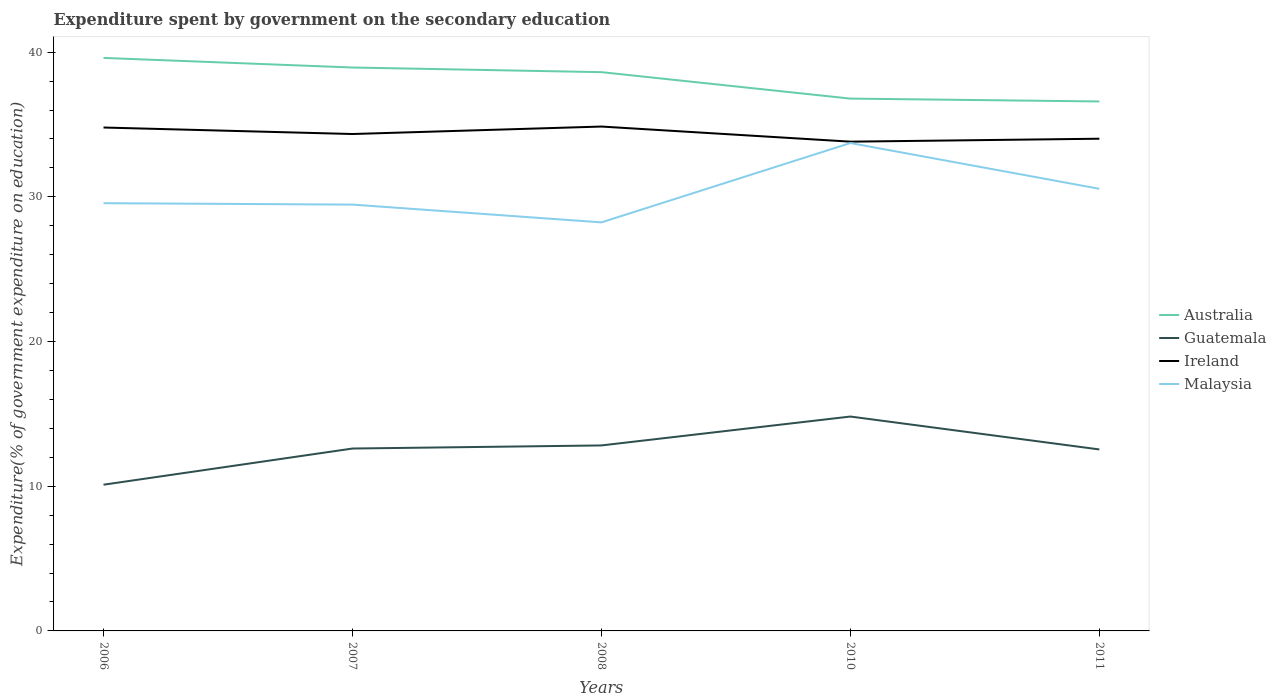Does the line corresponding to Ireland intersect with the line corresponding to Guatemala?
Offer a terse response. No. Across all years, what is the maximum expenditure spent by government on the secondary education in Malaysia?
Offer a terse response. 28.23. In which year was the expenditure spent by government on the secondary education in Australia maximum?
Keep it short and to the point. 2011. What is the total expenditure spent by government on the secondary education in Ireland in the graph?
Provide a short and direct response. 0.98. What is the difference between the highest and the second highest expenditure spent by government on the secondary education in Guatemala?
Provide a short and direct response. 4.71. What is the difference between the highest and the lowest expenditure spent by government on the secondary education in Ireland?
Your response must be concise. 2. Is the expenditure spent by government on the secondary education in Ireland strictly greater than the expenditure spent by government on the secondary education in Guatemala over the years?
Your response must be concise. No. How many lines are there?
Your response must be concise. 4. What is the difference between two consecutive major ticks on the Y-axis?
Provide a short and direct response. 10. Where does the legend appear in the graph?
Provide a succinct answer. Center right. How are the legend labels stacked?
Keep it short and to the point. Vertical. What is the title of the graph?
Make the answer very short. Expenditure spent by government on the secondary education. What is the label or title of the X-axis?
Your response must be concise. Years. What is the label or title of the Y-axis?
Offer a very short reply. Expenditure(% of government expenditure on education). What is the Expenditure(% of government expenditure on education) of Australia in 2006?
Provide a short and direct response. 39.6. What is the Expenditure(% of government expenditure on education) of Guatemala in 2006?
Your response must be concise. 10.11. What is the Expenditure(% of government expenditure on education) in Ireland in 2006?
Give a very brief answer. 34.79. What is the Expenditure(% of government expenditure on education) in Malaysia in 2006?
Your answer should be very brief. 29.56. What is the Expenditure(% of government expenditure on education) in Australia in 2007?
Ensure brevity in your answer.  38.94. What is the Expenditure(% of government expenditure on education) of Guatemala in 2007?
Give a very brief answer. 12.6. What is the Expenditure(% of government expenditure on education) of Ireland in 2007?
Your response must be concise. 34.34. What is the Expenditure(% of government expenditure on education) in Malaysia in 2007?
Your answer should be compact. 29.46. What is the Expenditure(% of government expenditure on education) of Australia in 2008?
Your answer should be compact. 38.62. What is the Expenditure(% of government expenditure on education) of Guatemala in 2008?
Offer a very short reply. 12.82. What is the Expenditure(% of government expenditure on education) of Ireland in 2008?
Provide a succinct answer. 34.86. What is the Expenditure(% of government expenditure on education) of Malaysia in 2008?
Keep it short and to the point. 28.23. What is the Expenditure(% of government expenditure on education) in Australia in 2010?
Provide a succinct answer. 36.79. What is the Expenditure(% of government expenditure on education) of Guatemala in 2010?
Offer a terse response. 14.82. What is the Expenditure(% of government expenditure on education) in Ireland in 2010?
Provide a short and direct response. 33.81. What is the Expenditure(% of government expenditure on education) of Malaysia in 2010?
Offer a terse response. 33.72. What is the Expenditure(% of government expenditure on education) of Australia in 2011?
Ensure brevity in your answer.  36.59. What is the Expenditure(% of government expenditure on education) of Guatemala in 2011?
Keep it short and to the point. 12.54. What is the Expenditure(% of government expenditure on education) of Ireland in 2011?
Make the answer very short. 34.02. What is the Expenditure(% of government expenditure on education) of Malaysia in 2011?
Keep it short and to the point. 30.55. Across all years, what is the maximum Expenditure(% of government expenditure on education) in Australia?
Make the answer very short. 39.6. Across all years, what is the maximum Expenditure(% of government expenditure on education) of Guatemala?
Ensure brevity in your answer.  14.82. Across all years, what is the maximum Expenditure(% of government expenditure on education) of Ireland?
Your response must be concise. 34.86. Across all years, what is the maximum Expenditure(% of government expenditure on education) in Malaysia?
Your response must be concise. 33.72. Across all years, what is the minimum Expenditure(% of government expenditure on education) in Australia?
Make the answer very short. 36.59. Across all years, what is the minimum Expenditure(% of government expenditure on education) of Guatemala?
Provide a succinct answer. 10.11. Across all years, what is the minimum Expenditure(% of government expenditure on education) in Ireland?
Give a very brief answer. 33.81. Across all years, what is the minimum Expenditure(% of government expenditure on education) in Malaysia?
Provide a short and direct response. 28.23. What is the total Expenditure(% of government expenditure on education) in Australia in the graph?
Make the answer very short. 190.53. What is the total Expenditure(% of government expenditure on education) in Guatemala in the graph?
Offer a terse response. 62.89. What is the total Expenditure(% of government expenditure on education) in Ireland in the graph?
Make the answer very short. 171.82. What is the total Expenditure(% of government expenditure on education) of Malaysia in the graph?
Your answer should be very brief. 151.53. What is the difference between the Expenditure(% of government expenditure on education) in Australia in 2006 and that in 2007?
Ensure brevity in your answer.  0.66. What is the difference between the Expenditure(% of government expenditure on education) of Guatemala in 2006 and that in 2007?
Provide a succinct answer. -2.5. What is the difference between the Expenditure(% of government expenditure on education) in Ireland in 2006 and that in 2007?
Your response must be concise. 0.45. What is the difference between the Expenditure(% of government expenditure on education) in Malaysia in 2006 and that in 2007?
Your response must be concise. 0.1. What is the difference between the Expenditure(% of government expenditure on education) in Australia in 2006 and that in 2008?
Provide a succinct answer. 0.98. What is the difference between the Expenditure(% of government expenditure on education) of Guatemala in 2006 and that in 2008?
Make the answer very short. -2.71. What is the difference between the Expenditure(% of government expenditure on education) of Ireland in 2006 and that in 2008?
Offer a terse response. -0.07. What is the difference between the Expenditure(% of government expenditure on education) of Malaysia in 2006 and that in 2008?
Ensure brevity in your answer.  1.33. What is the difference between the Expenditure(% of government expenditure on education) of Australia in 2006 and that in 2010?
Your answer should be very brief. 2.81. What is the difference between the Expenditure(% of government expenditure on education) in Guatemala in 2006 and that in 2010?
Your response must be concise. -4.71. What is the difference between the Expenditure(% of government expenditure on education) in Ireland in 2006 and that in 2010?
Your answer should be compact. 0.98. What is the difference between the Expenditure(% of government expenditure on education) in Malaysia in 2006 and that in 2010?
Your answer should be very brief. -4.16. What is the difference between the Expenditure(% of government expenditure on education) of Australia in 2006 and that in 2011?
Your answer should be very brief. 3.01. What is the difference between the Expenditure(% of government expenditure on education) of Guatemala in 2006 and that in 2011?
Offer a terse response. -2.44. What is the difference between the Expenditure(% of government expenditure on education) in Ireland in 2006 and that in 2011?
Make the answer very short. 0.77. What is the difference between the Expenditure(% of government expenditure on education) in Malaysia in 2006 and that in 2011?
Your answer should be compact. -0.99. What is the difference between the Expenditure(% of government expenditure on education) of Australia in 2007 and that in 2008?
Offer a terse response. 0.32. What is the difference between the Expenditure(% of government expenditure on education) in Guatemala in 2007 and that in 2008?
Provide a short and direct response. -0.21. What is the difference between the Expenditure(% of government expenditure on education) of Ireland in 2007 and that in 2008?
Your answer should be compact. -0.52. What is the difference between the Expenditure(% of government expenditure on education) in Malaysia in 2007 and that in 2008?
Ensure brevity in your answer.  1.23. What is the difference between the Expenditure(% of government expenditure on education) of Australia in 2007 and that in 2010?
Your answer should be very brief. 2.15. What is the difference between the Expenditure(% of government expenditure on education) in Guatemala in 2007 and that in 2010?
Provide a short and direct response. -2.21. What is the difference between the Expenditure(% of government expenditure on education) of Ireland in 2007 and that in 2010?
Make the answer very short. 0.53. What is the difference between the Expenditure(% of government expenditure on education) in Malaysia in 2007 and that in 2010?
Your answer should be compact. -4.25. What is the difference between the Expenditure(% of government expenditure on education) of Australia in 2007 and that in 2011?
Keep it short and to the point. 2.34. What is the difference between the Expenditure(% of government expenditure on education) in Guatemala in 2007 and that in 2011?
Give a very brief answer. 0.06. What is the difference between the Expenditure(% of government expenditure on education) of Ireland in 2007 and that in 2011?
Give a very brief answer. 0.33. What is the difference between the Expenditure(% of government expenditure on education) of Malaysia in 2007 and that in 2011?
Make the answer very short. -1.09. What is the difference between the Expenditure(% of government expenditure on education) of Australia in 2008 and that in 2010?
Your answer should be compact. 1.83. What is the difference between the Expenditure(% of government expenditure on education) in Guatemala in 2008 and that in 2010?
Offer a very short reply. -2. What is the difference between the Expenditure(% of government expenditure on education) of Ireland in 2008 and that in 2010?
Your answer should be very brief. 1.04. What is the difference between the Expenditure(% of government expenditure on education) of Malaysia in 2008 and that in 2010?
Ensure brevity in your answer.  -5.48. What is the difference between the Expenditure(% of government expenditure on education) in Australia in 2008 and that in 2011?
Offer a very short reply. 2.03. What is the difference between the Expenditure(% of government expenditure on education) of Guatemala in 2008 and that in 2011?
Make the answer very short. 0.28. What is the difference between the Expenditure(% of government expenditure on education) of Ireland in 2008 and that in 2011?
Your response must be concise. 0.84. What is the difference between the Expenditure(% of government expenditure on education) of Malaysia in 2008 and that in 2011?
Provide a short and direct response. -2.32. What is the difference between the Expenditure(% of government expenditure on education) in Australia in 2010 and that in 2011?
Your response must be concise. 0.2. What is the difference between the Expenditure(% of government expenditure on education) in Guatemala in 2010 and that in 2011?
Your answer should be very brief. 2.27. What is the difference between the Expenditure(% of government expenditure on education) of Ireland in 2010 and that in 2011?
Your answer should be very brief. -0.2. What is the difference between the Expenditure(% of government expenditure on education) of Malaysia in 2010 and that in 2011?
Provide a short and direct response. 3.16. What is the difference between the Expenditure(% of government expenditure on education) in Australia in 2006 and the Expenditure(% of government expenditure on education) in Guatemala in 2007?
Ensure brevity in your answer.  27. What is the difference between the Expenditure(% of government expenditure on education) in Australia in 2006 and the Expenditure(% of government expenditure on education) in Ireland in 2007?
Offer a terse response. 5.26. What is the difference between the Expenditure(% of government expenditure on education) of Australia in 2006 and the Expenditure(% of government expenditure on education) of Malaysia in 2007?
Provide a succinct answer. 10.14. What is the difference between the Expenditure(% of government expenditure on education) in Guatemala in 2006 and the Expenditure(% of government expenditure on education) in Ireland in 2007?
Your answer should be very brief. -24.24. What is the difference between the Expenditure(% of government expenditure on education) in Guatemala in 2006 and the Expenditure(% of government expenditure on education) in Malaysia in 2007?
Offer a very short reply. -19.36. What is the difference between the Expenditure(% of government expenditure on education) in Ireland in 2006 and the Expenditure(% of government expenditure on education) in Malaysia in 2007?
Provide a short and direct response. 5.33. What is the difference between the Expenditure(% of government expenditure on education) of Australia in 2006 and the Expenditure(% of government expenditure on education) of Guatemala in 2008?
Your answer should be compact. 26.78. What is the difference between the Expenditure(% of government expenditure on education) in Australia in 2006 and the Expenditure(% of government expenditure on education) in Ireland in 2008?
Your answer should be very brief. 4.74. What is the difference between the Expenditure(% of government expenditure on education) of Australia in 2006 and the Expenditure(% of government expenditure on education) of Malaysia in 2008?
Your answer should be very brief. 11.37. What is the difference between the Expenditure(% of government expenditure on education) of Guatemala in 2006 and the Expenditure(% of government expenditure on education) of Ireland in 2008?
Keep it short and to the point. -24.75. What is the difference between the Expenditure(% of government expenditure on education) in Guatemala in 2006 and the Expenditure(% of government expenditure on education) in Malaysia in 2008?
Your answer should be very brief. -18.13. What is the difference between the Expenditure(% of government expenditure on education) in Ireland in 2006 and the Expenditure(% of government expenditure on education) in Malaysia in 2008?
Provide a short and direct response. 6.56. What is the difference between the Expenditure(% of government expenditure on education) in Australia in 2006 and the Expenditure(% of government expenditure on education) in Guatemala in 2010?
Keep it short and to the point. 24.78. What is the difference between the Expenditure(% of government expenditure on education) in Australia in 2006 and the Expenditure(% of government expenditure on education) in Ireland in 2010?
Your answer should be very brief. 5.79. What is the difference between the Expenditure(% of government expenditure on education) in Australia in 2006 and the Expenditure(% of government expenditure on education) in Malaysia in 2010?
Offer a very short reply. 5.88. What is the difference between the Expenditure(% of government expenditure on education) of Guatemala in 2006 and the Expenditure(% of government expenditure on education) of Ireland in 2010?
Ensure brevity in your answer.  -23.71. What is the difference between the Expenditure(% of government expenditure on education) of Guatemala in 2006 and the Expenditure(% of government expenditure on education) of Malaysia in 2010?
Your response must be concise. -23.61. What is the difference between the Expenditure(% of government expenditure on education) of Ireland in 2006 and the Expenditure(% of government expenditure on education) of Malaysia in 2010?
Your answer should be very brief. 1.07. What is the difference between the Expenditure(% of government expenditure on education) in Australia in 2006 and the Expenditure(% of government expenditure on education) in Guatemala in 2011?
Make the answer very short. 27.06. What is the difference between the Expenditure(% of government expenditure on education) in Australia in 2006 and the Expenditure(% of government expenditure on education) in Ireland in 2011?
Give a very brief answer. 5.58. What is the difference between the Expenditure(% of government expenditure on education) of Australia in 2006 and the Expenditure(% of government expenditure on education) of Malaysia in 2011?
Ensure brevity in your answer.  9.05. What is the difference between the Expenditure(% of government expenditure on education) in Guatemala in 2006 and the Expenditure(% of government expenditure on education) in Ireland in 2011?
Make the answer very short. -23.91. What is the difference between the Expenditure(% of government expenditure on education) in Guatemala in 2006 and the Expenditure(% of government expenditure on education) in Malaysia in 2011?
Your answer should be compact. -20.45. What is the difference between the Expenditure(% of government expenditure on education) in Ireland in 2006 and the Expenditure(% of government expenditure on education) in Malaysia in 2011?
Provide a short and direct response. 4.24. What is the difference between the Expenditure(% of government expenditure on education) in Australia in 2007 and the Expenditure(% of government expenditure on education) in Guatemala in 2008?
Make the answer very short. 26.12. What is the difference between the Expenditure(% of government expenditure on education) in Australia in 2007 and the Expenditure(% of government expenditure on education) in Ireland in 2008?
Ensure brevity in your answer.  4.08. What is the difference between the Expenditure(% of government expenditure on education) in Australia in 2007 and the Expenditure(% of government expenditure on education) in Malaysia in 2008?
Make the answer very short. 10.7. What is the difference between the Expenditure(% of government expenditure on education) in Guatemala in 2007 and the Expenditure(% of government expenditure on education) in Ireland in 2008?
Keep it short and to the point. -22.25. What is the difference between the Expenditure(% of government expenditure on education) of Guatemala in 2007 and the Expenditure(% of government expenditure on education) of Malaysia in 2008?
Your response must be concise. -15.63. What is the difference between the Expenditure(% of government expenditure on education) in Ireland in 2007 and the Expenditure(% of government expenditure on education) in Malaysia in 2008?
Offer a very short reply. 6.11. What is the difference between the Expenditure(% of government expenditure on education) of Australia in 2007 and the Expenditure(% of government expenditure on education) of Guatemala in 2010?
Offer a very short reply. 24.12. What is the difference between the Expenditure(% of government expenditure on education) of Australia in 2007 and the Expenditure(% of government expenditure on education) of Ireland in 2010?
Your response must be concise. 5.12. What is the difference between the Expenditure(% of government expenditure on education) in Australia in 2007 and the Expenditure(% of government expenditure on education) in Malaysia in 2010?
Keep it short and to the point. 5.22. What is the difference between the Expenditure(% of government expenditure on education) of Guatemala in 2007 and the Expenditure(% of government expenditure on education) of Ireland in 2010?
Provide a short and direct response. -21.21. What is the difference between the Expenditure(% of government expenditure on education) of Guatemala in 2007 and the Expenditure(% of government expenditure on education) of Malaysia in 2010?
Offer a terse response. -21.11. What is the difference between the Expenditure(% of government expenditure on education) in Ireland in 2007 and the Expenditure(% of government expenditure on education) in Malaysia in 2010?
Make the answer very short. 0.62. What is the difference between the Expenditure(% of government expenditure on education) of Australia in 2007 and the Expenditure(% of government expenditure on education) of Guatemala in 2011?
Keep it short and to the point. 26.39. What is the difference between the Expenditure(% of government expenditure on education) in Australia in 2007 and the Expenditure(% of government expenditure on education) in Ireland in 2011?
Offer a terse response. 4.92. What is the difference between the Expenditure(% of government expenditure on education) in Australia in 2007 and the Expenditure(% of government expenditure on education) in Malaysia in 2011?
Offer a terse response. 8.38. What is the difference between the Expenditure(% of government expenditure on education) in Guatemala in 2007 and the Expenditure(% of government expenditure on education) in Ireland in 2011?
Offer a very short reply. -21.41. What is the difference between the Expenditure(% of government expenditure on education) of Guatemala in 2007 and the Expenditure(% of government expenditure on education) of Malaysia in 2011?
Give a very brief answer. -17.95. What is the difference between the Expenditure(% of government expenditure on education) in Ireland in 2007 and the Expenditure(% of government expenditure on education) in Malaysia in 2011?
Your answer should be very brief. 3.79. What is the difference between the Expenditure(% of government expenditure on education) of Australia in 2008 and the Expenditure(% of government expenditure on education) of Guatemala in 2010?
Give a very brief answer. 23.8. What is the difference between the Expenditure(% of government expenditure on education) in Australia in 2008 and the Expenditure(% of government expenditure on education) in Ireland in 2010?
Ensure brevity in your answer.  4.8. What is the difference between the Expenditure(% of government expenditure on education) in Australia in 2008 and the Expenditure(% of government expenditure on education) in Malaysia in 2010?
Offer a very short reply. 4.9. What is the difference between the Expenditure(% of government expenditure on education) in Guatemala in 2008 and the Expenditure(% of government expenditure on education) in Ireland in 2010?
Ensure brevity in your answer.  -20.99. What is the difference between the Expenditure(% of government expenditure on education) of Guatemala in 2008 and the Expenditure(% of government expenditure on education) of Malaysia in 2010?
Offer a terse response. -20.9. What is the difference between the Expenditure(% of government expenditure on education) in Ireland in 2008 and the Expenditure(% of government expenditure on education) in Malaysia in 2010?
Make the answer very short. 1.14. What is the difference between the Expenditure(% of government expenditure on education) of Australia in 2008 and the Expenditure(% of government expenditure on education) of Guatemala in 2011?
Provide a succinct answer. 26.07. What is the difference between the Expenditure(% of government expenditure on education) in Australia in 2008 and the Expenditure(% of government expenditure on education) in Ireland in 2011?
Provide a succinct answer. 4.6. What is the difference between the Expenditure(% of government expenditure on education) in Australia in 2008 and the Expenditure(% of government expenditure on education) in Malaysia in 2011?
Make the answer very short. 8.06. What is the difference between the Expenditure(% of government expenditure on education) in Guatemala in 2008 and the Expenditure(% of government expenditure on education) in Ireland in 2011?
Ensure brevity in your answer.  -21.2. What is the difference between the Expenditure(% of government expenditure on education) in Guatemala in 2008 and the Expenditure(% of government expenditure on education) in Malaysia in 2011?
Ensure brevity in your answer.  -17.74. What is the difference between the Expenditure(% of government expenditure on education) in Ireland in 2008 and the Expenditure(% of government expenditure on education) in Malaysia in 2011?
Provide a short and direct response. 4.3. What is the difference between the Expenditure(% of government expenditure on education) in Australia in 2010 and the Expenditure(% of government expenditure on education) in Guatemala in 2011?
Your answer should be compact. 24.25. What is the difference between the Expenditure(% of government expenditure on education) of Australia in 2010 and the Expenditure(% of government expenditure on education) of Ireland in 2011?
Ensure brevity in your answer.  2.77. What is the difference between the Expenditure(% of government expenditure on education) in Australia in 2010 and the Expenditure(% of government expenditure on education) in Malaysia in 2011?
Offer a very short reply. 6.23. What is the difference between the Expenditure(% of government expenditure on education) in Guatemala in 2010 and the Expenditure(% of government expenditure on education) in Ireland in 2011?
Provide a short and direct response. -19.2. What is the difference between the Expenditure(% of government expenditure on education) in Guatemala in 2010 and the Expenditure(% of government expenditure on education) in Malaysia in 2011?
Make the answer very short. -15.74. What is the difference between the Expenditure(% of government expenditure on education) of Ireland in 2010 and the Expenditure(% of government expenditure on education) of Malaysia in 2011?
Your answer should be compact. 3.26. What is the average Expenditure(% of government expenditure on education) of Australia per year?
Your answer should be very brief. 38.11. What is the average Expenditure(% of government expenditure on education) of Guatemala per year?
Provide a succinct answer. 12.58. What is the average Expenditure(% of government expenditure on education) in Ireland per year?
Your response must be concise. 34.36. What is the average Expenditure(% of government expenditure on education) of Malaysia per year?
Provide a short and direct response. 30.31. In the year 2006, what is the difference between the Expenditure(% of government expenditure on education) of Australia and Expenditure(% of government expenditure on education) of Guatemala?
Ensure brevity in your answer.  29.5. In the year 2006, what is the difference between the Expenditure(% of government expenditure on education) in Australia and Expenditure(% of government expenditure on education) in Ireland?
Your answer should be very brief. 4.81. In the year 2006, what is the difference between the Expenditure(% of government expenditure on education) of Australia and Expenditure(% of government expenditure on education) of Malaysia?
Give a very brief answer. 10.04. In the year 2006, what is the difference between the Expenditure(% of government expenditure on education) in Guatemala and Expenditure(% of government expenditure on education) in Ireland?
Ensure brevity in your answer.  -24.68. In the year 2006, what is the difference between the Expenditure(% of government expenditure on education) in Guatemala and Expenditure(% of government expenditure on education) in Malaysia?
Provide a succinct answer. -19.46. In the year 2006, what is the difference between the Expenditure(% of government expenditure on education) of Ireland and Expenditure(% of government expenditure on education) of Malaysia?
Ensure brevity in your answer.  5.23. In the year 2007, what is the difference between the Expenditure(% of government expenditure on education) of Australia and Expenditure(% of government expenditure on education) of Guatemala?
Provide a succinct answer. 26.33. In the year 2007, what is the difference between the Expenditure(% of government expenditure on education) of Australia and Expenditure(% of government expenditure on education) of Ireland?
Keep it short and to the point. 4.6. In the year 2007, what is the difference between the Expenditure(% of government expenditure on education) in Australia and Expenditure(% of government expenditure on education) in Malaysia?
Offer a terse response. 9.47. In the year 2007, what is the difference between the Expenditure(% of government expenditure on education) in Guatemala and Expenditure(% of government expenditure on education) in Ireland?
Your response must be concise. -21.74. In the year 2007, what is the difference between the Expenditure(% of government expenditure on education) of Guatemala and Expenditure(% of government expenditure on education) of Malaysia?
Your response must be concise. -16.86. In the year 2007, what is the difference between the Expenditure(% of government expenditure on education) of Ireland and Expenditure(% of government expenditure on education) of Malaysia?
Offer a very short reply. 4.88. In the year 2008, what is the difference between the Expenditure(% of government expenditure on education) in Australia and Expenditure(% of government expenditure on education) in Guatemala?
Your response must be concise. 25.8. In the year 2008, what is the difference between the Expenditure(% of government expenditure on education) in Australia and Expenditure(% of government expenditure on education) in Ireland?
Provide a succinct answer. 3.76. In the year 2008, what is the difference between the Expenditure(% of government expenditure on education) of Australia and Expenditure(% of government expenditure on education) of Malaysia?
Your answer should be very brief. 10.38. In the year 2008, what is the difference between the Expenditure(% of government expenditure on education) in Guatemala and Expenditure(% of government expenditure on education) in Ireland?
Your answer should be compact. -22.04. In the year 2008, what is the difference between the Expenditure(% of government expenditure on education) in Guatemala and Expenditure(% of government expenditure on education) in Malaysia?
Provide a short and direct response. -15.42. In the year 2008, what is the difference between the Expenditure(% of government expenditure on education) in Ireland and Expenditure(% of government expenditure on education) in Malaysia?
Provide a succinct answer. 6.62. In the year 2010, what is the difference between the Expenditure(% of government expenditure on education) of Australia and Expenditure(% of government expenditure on education) of Guatemala?
Your response must be concise. 21.97. In the year 2010, what is the difference between the Expenditure(% of government expenditure on education) of Australia and Expenditure(% of government expenditure on education) of Ireland?
Provide a succinct answer. 2.98. In the year 2010, what is the difference between the Expenditure(% of government expenditure on education) in Australia and Expenditure(% of government expenditure on education) in Malaysia?
Give a very brief answer. 3.07. In the year 2010, what is the difference between the Expenditure(% of government expenditure on education) in Guatemala and Expenditure(% of government expenditure on education) in Ireland?
Provide a succinct answer. -19. In the year 2010, what is the difference between the Expenditure(% of government expenditure on education) in Guatemala and Expenditure(% of government expenditure on education) in Malaysia?
Your response must be concise. -18.9. In the year 2010, what is the difference between the Expenditure(% of government expenditure on education) of Ireland and Expenditure(% of government expenditure on education) of Malaysia?
Offer a very short reply. 0.1. In the year 2011, what is the difference between the Expenditure(% of government expenditure on education) of Australia and Expenditure(% of government expenditure on education) of Guatemala?
Ensure brevity in your answer.  24.05. In the year 2011, what is the difference between the Expenditure(% of government expenditure on education) of Australia and Expenditure(% of government expenditure on education) of Ireland?
Ensure brevity in your answer.  2.58. In the year 2011, what is the difference between the Expenditure(% of government expenditure on education) in Australia and Expenditure(% of government expenditure on education) in Malaysia?
Keep it short and to the point. 6.04. In the year 2011, what is the difference between the Expenditure(% of government expenditure on education) of Guatemala and Expenditure(% of government expenditure on education) of Ireland?
Your answer should be compact. -21.47. In the year 2011, what is the difference between the Expenditure(% of government expenditure on education) of Guatemala and Expenditure(% of government expenditure on education) of Malaysia?
Give a very brief answer. -18.01. In the year 2011, what is the difference between the Expenditure(% of government expenditure on education) of Ireland and Expenditure(% of government expenditure on education) of Malaysia?
Offer a very short reply. 3.46. What is the ratio of the Expenditure(% of government expenditure on education) in Australia in 2006 to that in 2007?
Make the answer very short. 1.02. What is the ratio of the Expenditure(% of government expenditure on education) in Guatemala in 2006 to that in 2007?
Ensure brevity in your answer.  0.8. What is the ratio of the Expenditure(% of government expenditure on education) in Ireland in 2006 to that in 2007?
Your answer should be very brief. 1.01. What is the ratio of the Expenditure(% of government expenditure on education) in Malaysia in 2006 to that in 2007?
Give a very brief answer. 1. What is the ratio of the Expenditure(% of government expenditure on education) in Australia in 2006 to that in 2008?
Offer a terse response. 1.03. What is the ratio of the Expenditure(% of government expenditure on education) in Guatemala in 2006 to that in 2008?
Keep it short and to the point. 0.79. What is the ratio of the Expenditure(% of government expenditure on education) in Ireland in 2006 to that in 2008?
Your response must be concise. 1. What is the ratio of the Expenditure(% of government expenditure on education) in Malaysia in 2006 to that in 2008?
Provide a short and direct response. 1.05. What is the ratio of the Expenditure(% of government expenditure on education) of Australia in 2006 to that in 2010?
Provide a short and direct response. 1.08. What is the ratio of the Expenditure(% of government expenditure on education) in Guatemala in 2006 to that in 2010?
Your response must be concise. 0.68. What is the ratio of the Expenditure(% of government expenditure on education) in Ireland in 2006 to that in 2010?
Provide a succinct answer. 1.03. What is the ratio of the Expenditure(% of government expenditure on education) in Malaysia in 2006 to that in 2010?
Your response must be concise. 0.88. What is the ratio of the Expenditure(% of government expenditure on education) in Australia in 2006 to that in 2011?
Provide a succinct answer. 1.08. What is the ratio of the Expenditure(% of government expenditure on education) in Guatemala in 2006 to that in 2011?
Your response must be concise. 0.81. What is the ratio of the Expenditure(% of government expenditure on education) in Ireland in 2006 to that in 2011?
Your answer should be compact. 1.02. What is the ratio of the Expenditure(% of government expenditure on education) of Malaysia in 2006 to that in 2011?
Provide a short and direct response. 0.97. What is the ratio of the Expenditure(% of government expenditure on education) of Australia in 2007 to that in 2008?
Your answer should be very brief. 1.01. What is the ratio of the Expenditure(% of government expenditure on education) of Guatemala in 2007 to that in 2008?
Keep it short and to the point. 0.98. What is the ratio of the Expenditure(% of government expenditure on education) in Ireland in 2007 to that in 2008?
Make the answer very short. 0.99. What is the ratio of the Expenditure(% of government expenditure on education) of Malaysia in 2007 to that in 2008?
Provide a succinct answer. 1.04. What is the ratio of the Expenditure(% of government expenditure on education) in Australia in 2007 to that in 2010?
Offer a very short reply. 1.06. What is the ratio of the Expenditure(% of government expenditure on education) in Guatemala in 2007 to that in 2010?
Provide a short and direct response. 0.85. What is the ratio of the Expenditure(% of government expenditure on education) in Ireland in 2007 to that in 2010?
Provide a short and direct response. 1.02. What is the ratio of the Expenditure(% of government expenditure on education) in Malaysia in 2007 to that in 2010?
Ensure brevity in your answer.  0.87. What is the ratio of the Expenditure(% of government expenditure on education) in Australia in 2007 to that in 2011?
Your answer should be very brief. 1.06. What is the ratio of the Expenditure(% of government expenditure on education) in Ireland in 2007 to that in 2011?
Provide a succinct answer. 1.01. What is the ratio of the Expenditure(% of government expenditure on education) of Malaysia in 2007 to that in 2011?
Your response must be concise. 0.96. What is the ratio of the Expenditure(% of government expenditure on education) in Australia in 2008 to that in 2010?
Your response must be concise. 1.05. What is the ratio of the Expenditure(% of government expenditure on education) of Guatemala in 2008 to that in 2010?
Your answer should be compact. 0.87. What is the ratio of the Expenditure(% of government expenditure on education) of Ireland in 2008 to that in 2010?
Keep it short and to the point. 1.03. What is the ratio of the Expenditure(% of government expenditure on education) of Malaysia in 2008 to that in 2010?
Keep it short and to the point. 0.84. What is the ratio of the Expenditure(% of government expenditure on education) of Australia in 2008 to that in 2011?
Your response must be concise. 1.06. What is the ratio of the Expenditure(% of government expenditure on education) in Guatemala in 2008 to that in 2011?
Your answer should be compact. 1.02. What is the ratio of the Expenditure(% of government expenditure on education) in Ireland in 2008 to that in 2011?
Make the answer very short. 1.02. What is the ratio of the Expenditure(% of government expenditure on education) in Malaysia in 2008 to that in 2011?
Offer a very short reply. 0.92. What is the ratio of the Expenditure(% of government expenditure on education) of Australia in 2010 to that in 2011?
Your answer should be compact. 1.01. What is the ratio of the Expenditure(% of government expenditure on education) of Guatemala in 2010 to that in 2011?
Make the answer very short. 1.18. What is the ratio of the Expenditure(% of government expenditure on education) in Ireland in 2010 to that in 2011?
Your answer should be compact. 0.99. What is the ratio of the Expenditure(% of government expenditure on education) in Malaysia in 2010 to that in 2011?
Your answer should be compact. 1.1. What is the difference between the highest and the second highest Expenditure(% of government expenditure on education) in Australia?
Your answer should be compact. 0.66. What is the difference between the highest and the second highest Expenditure(% of government expenditure on education) of Guatemala?
Provide a short and direct response. 2. What is the difference between the highest and the second highest Expenditure(% of government expenditure on education) in Ireland?
Provide a short and direct response. 0.07. What is the difference between the highest and the second highest Expenditure(% of government expenditure on education) in Malaysia?
Offer a terse response. 3.16. What is the difference between the highest and the lowest Expenditure(% of government expenditure on education) in Australia?
Your response must be concise. 3.01. What is the difference between the highest and the lowest Expenditure(% of government expenditure on education) of Guatemala?
Offer a terse response. 4.71. What is the difference between the highest and the lowest Expenditure(% of government expenditure on education) in Ireland?
Ensure brevity in your answer.  1.04. What is the difference between the highest and the lowest Expenditure(% of government expenditure on education) of Malaysia?
Give a very brief answer. 5.48. 